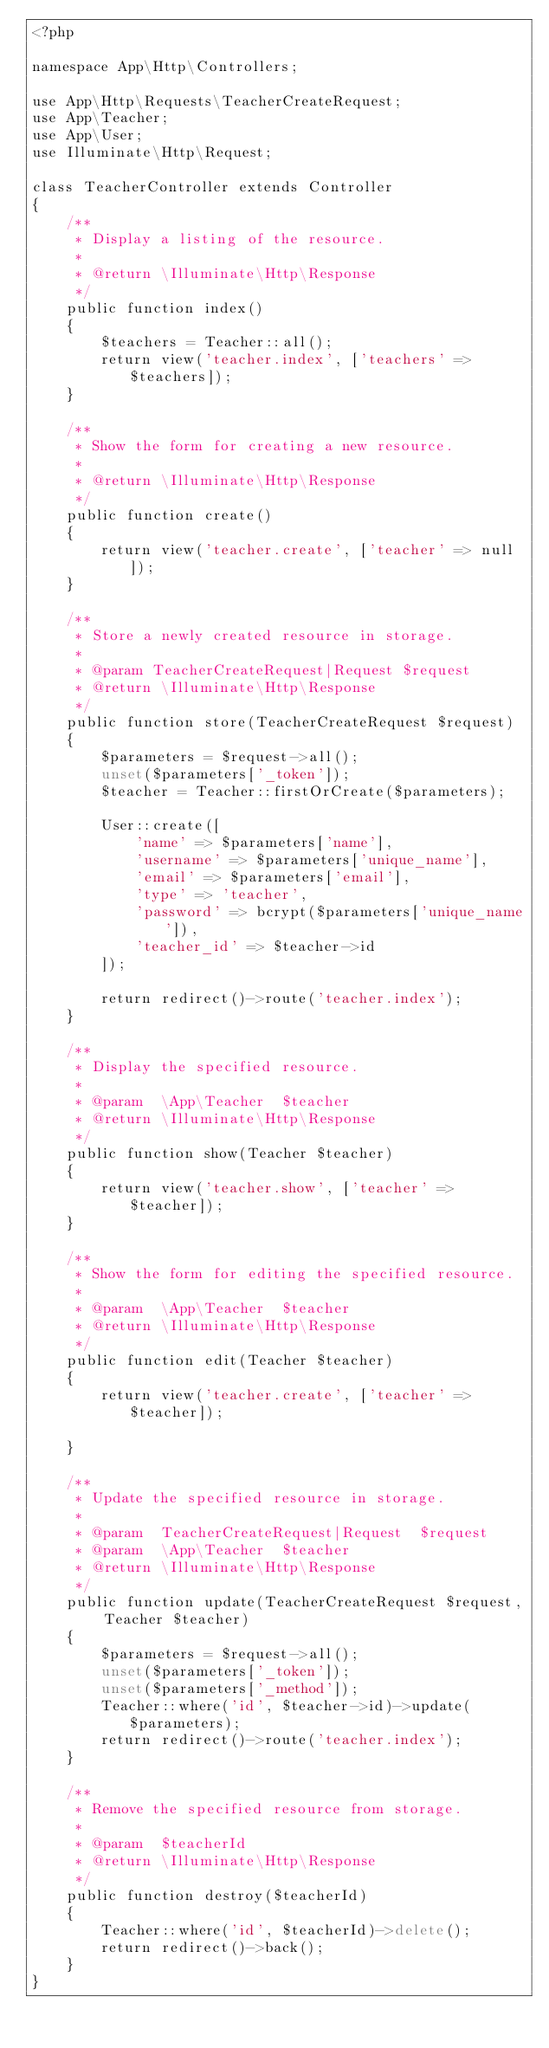<code> <loc_0><loc_0><loc_500><loc_500><_PHP_><?php

namespace App\Http\Controllers;

use App\Http\Requests\TeacherCreateRequest;
use App\Teacher;
use App\User;
use Illuminate\Http\Request;

class TeacherController extends Controller
{
    /**
     * Display a listing of the resource.
     *
     * @return \Illuminate\Http\Response
     */
    public function index()
    {
        $teachers = Teacher::all();
        return view('teacher.index', ['teachers' => $teachers]);
    }

    /**
     * Show the form for creating a new resource.
     *
     * @return \Illuminate\Http\Response
     */
    public function create()
    {
        return view('teacher.create', ['teacher' => null]);
    }

    /**
     * Store a newly created resource in storage.
     *
     * @param TeacherCreateRequest|Request $request
     * @return \Illuminate\Http\Response
     */
    public function store(TeacherCreateRequest $request)
    {
        $parameters = $request->all();
        unset($parameters['_token']);
        $teacher = Teacher::firstOrCreate($parameters);

        User::create([
            'name' => $parameters['name'],
            'username' => $parameters['unique_name'],
            'email' => $parameters['email'],
            'type' => 'teacher',
            'password' => bcrypt($parameters['unique_name']),
            'teacher_id' => $teacher->id
        ]);

        return redirect()->route('teacher.index');
    }

    /**
     * Display the specified resource.
     *
     * @param  \App\Teacher  $teacher
     * @return \Illuminate\Http\Response
     */
    public function show(Teacher $teacher)
    {
        return view('teacher.show', ['teacher' => $teacher]);
    }

    /**
     * Show the form for editing the specified resource.
     *
     * @param  \App\Teacher  $teacher
     * @return \Illuminate\Http\Response
     */
    public function edit(Teacher $teacher)
    {
        return view('teacher.create', ['teacher' => $teacher]);

    }

    /**
     * Update the specified resource in storage.
     *
     * @param  TeacherCreateRequest|Request  $request
     * @param  \App\Teacher  $teacher
     * @return \Illuminate\Http\Response
     */
    public function update(TeacherCreateRequest $request, Teacher $teacher)
    {
        $parameters = $request->all();
        unset($parameters['_token']);
        unset($parameters['_method']);
        Teacher::where('id', $teacher->id)->update($parameters);
        return redirect()->route('teacher.index');
    }

    /**
     * Remove the specified resource from storage.
     *
     * @param  $teacherId
     * @return \Illuminate\Http\Response
     */
    public function destroy($teacherId)
    {
        Teacher::where('id', $teacherId)->delete();
        return redirect()->back();
    }
}
</code> 